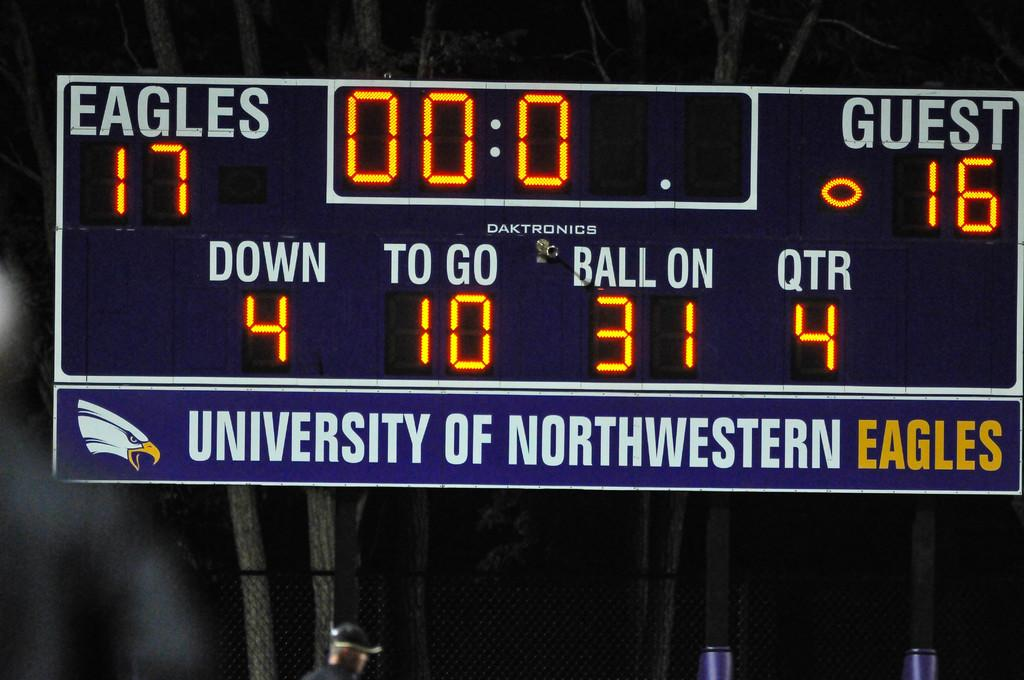Provide a one-sentence caption for the provided image. The University of Northwestern Eagles scoreboard shows that score as Eagles 17, Guest 16 in the 4th Quarter. 